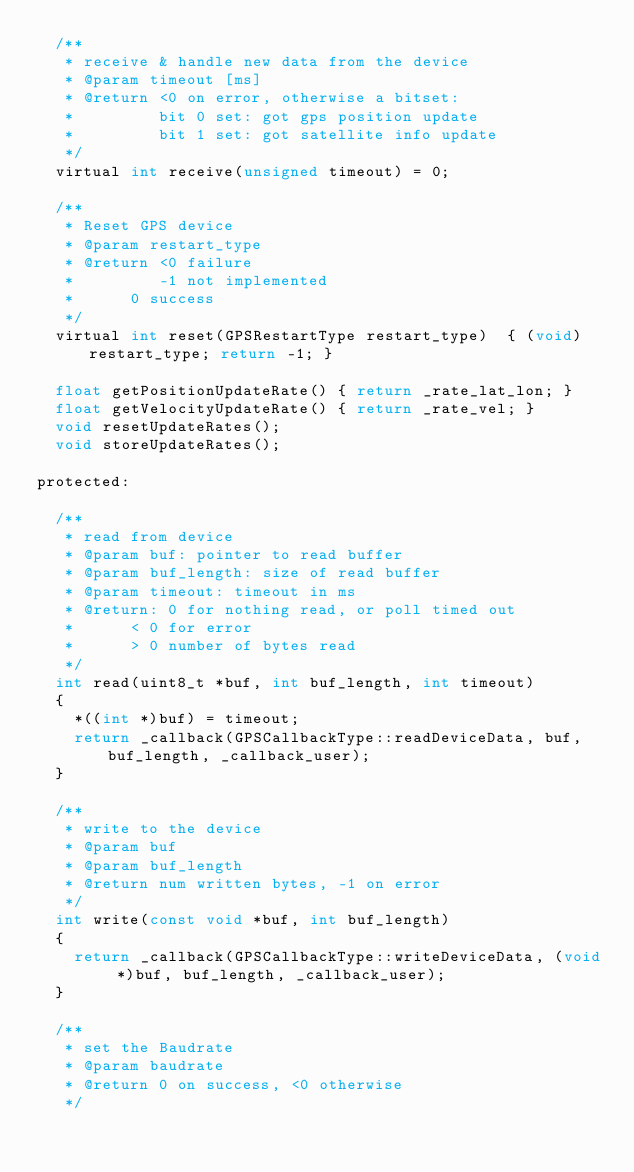<code> <loc_0><loc_0><loc_500><loc_500><_C_>	/**
	 * receive & handle new data from the device
	 * @param timeout [ms]
	 * @return <0 on error, otherwise a bitset:
	 *         bit 0 set: got gps position update
	 *         bit 1 set: got satellite info update
	 */
	virtual int receive(unsigned timeout) = 0;

	/**
	 * Reset GPS device
	 * @param restart_type
	 * @return <0 failure
	 *         -1 not implemented
	 * 	    0 success
	 */
	virtual int reset(GPSRestartType restart_type)	{ (void)restart_type; return -1; }

	float getPositionUpdateRate() { return _rate_lat_lon; }
	float getVelocityUpdateRate() { return _rate_vel; }
	void resetUpdateRates();
	void storeUpdateRates();

protected:

	/**
	 * read from device
	 * @param buf: pointer to read buffer
	 * @param buf_length: size of read buffer
	 * @param timeout: timeout in ms
	 * @return: 0 for nothing read, or poll timed out
	 *	    < 0 for error
	 *	    > 0 number of bytes read
	 */
	int read(uint8_t *buf, int buf_length, int timeout)
	{
		*((int *)buf) = timeout;
		return _callback(GPSCallbackType::readDeviceData, buf, buf_length, _callback_user);
	}

	/**
	 * write to the device
	 * @param buf
	 * @param buf_length
	 * @return num written bytes, -1 on error
	 */
	int write(const void *buf, int buf_length)
	{
		return _callback(GPSCallbackType::writeDeviceData, (void *)buf, buf_length, _callback_user);
	}

	/**
	 * set the Baudrate
	 * @param baudrate
	 * @return 0 on success, <0 otherwise
	 */</code> 